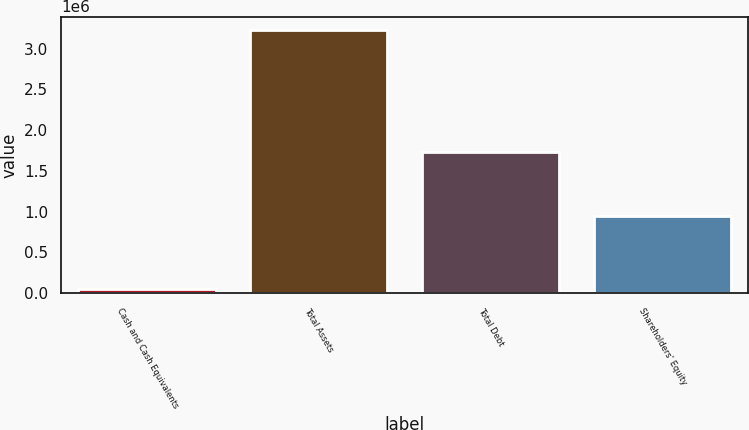Convert chart to OTSL. <chart><loc_0><loc_0><loc_500><loc_500><bar_chart><fcel>Cash and Cash Equivalents<fcel>Total Assets<fcel>Total Debt<fcel>Shareholders' Equity<nl><fcel>56292<fcel>3.23066e+06<fcel>1.7321e+06<fcel>944861<nl></chart> 